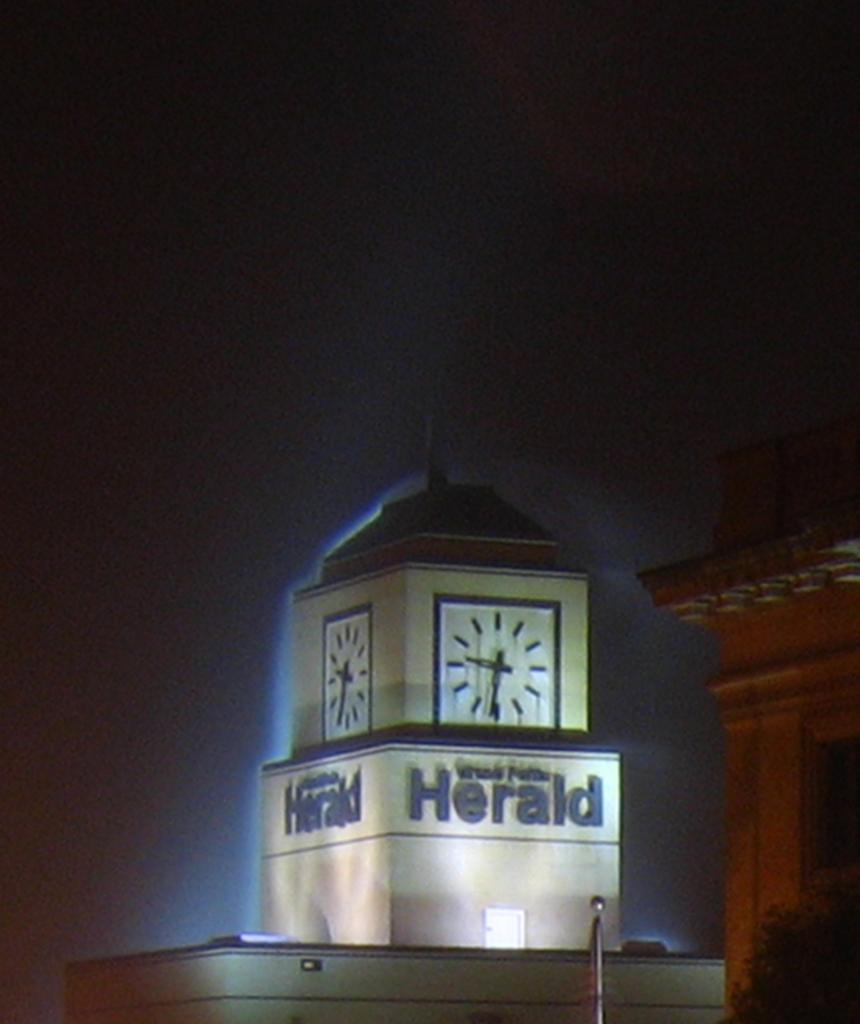What is written on the clock tower?
Ensure brevity in your answer.  Herald. 